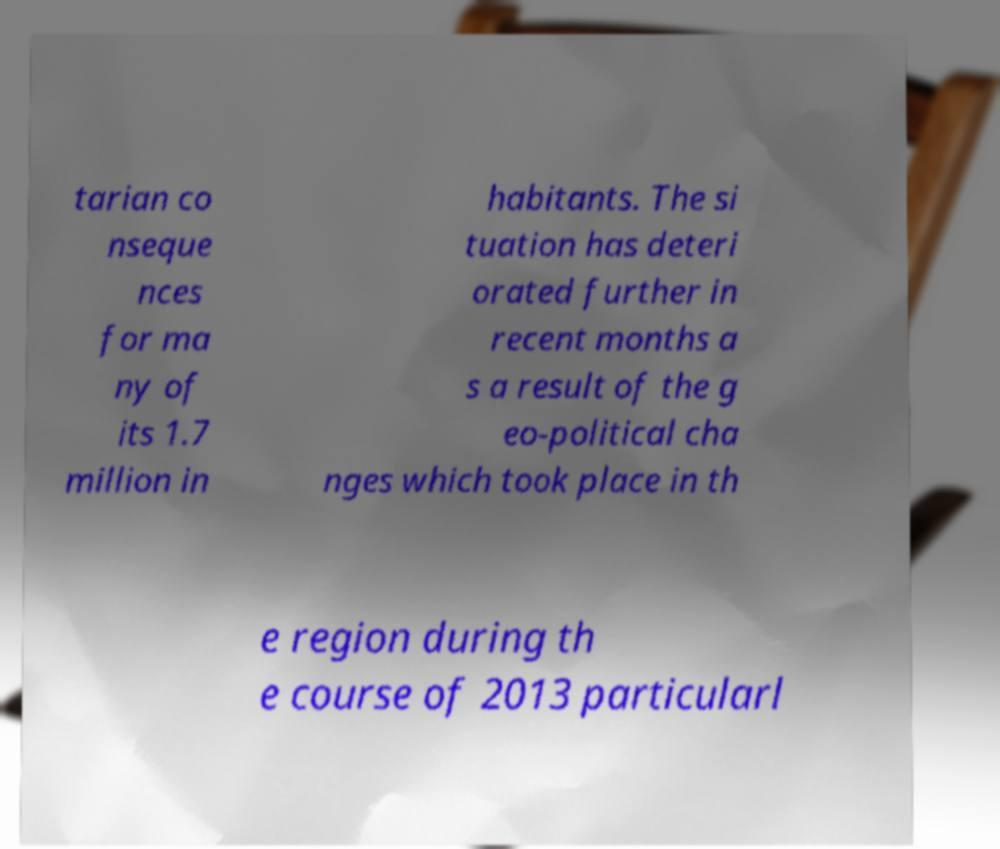What messages or text are displayed in this image? I need them in a readable, typed format. tarian co nseque nces for ma ny of its 1.7 million in habitants. The si tuation has deteri orated further in recent months a s a result of the g eo-political cha nges which took place in th e region during th e course of 2013 particularl 